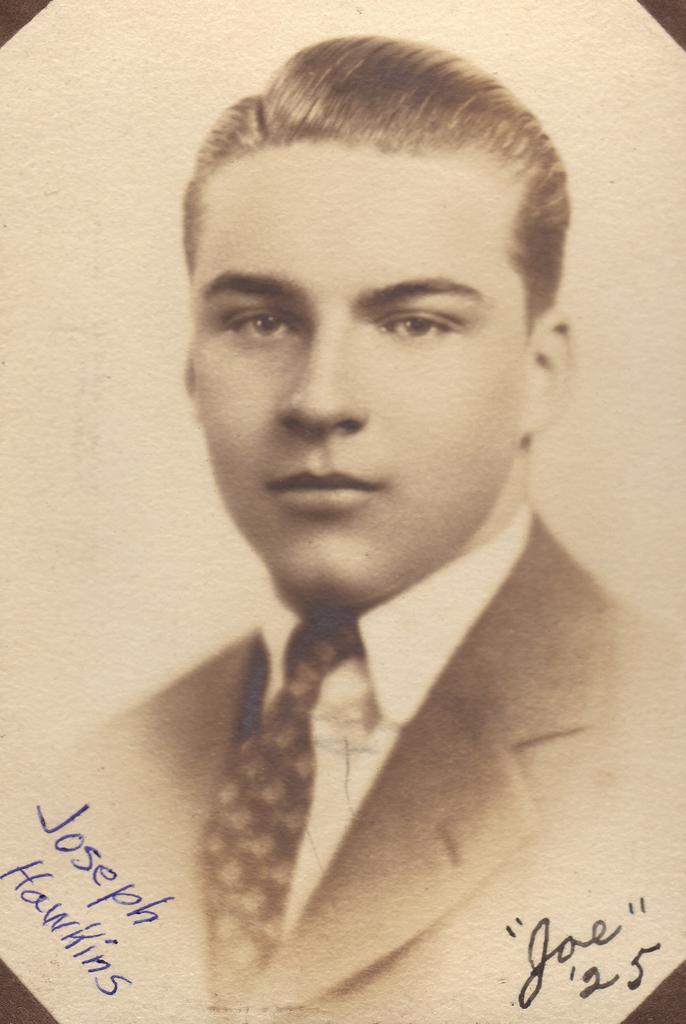Describe this image in one or two sentences. In the image there is a man image with jacket, shirt and tie. And on the image there is something written on it. 